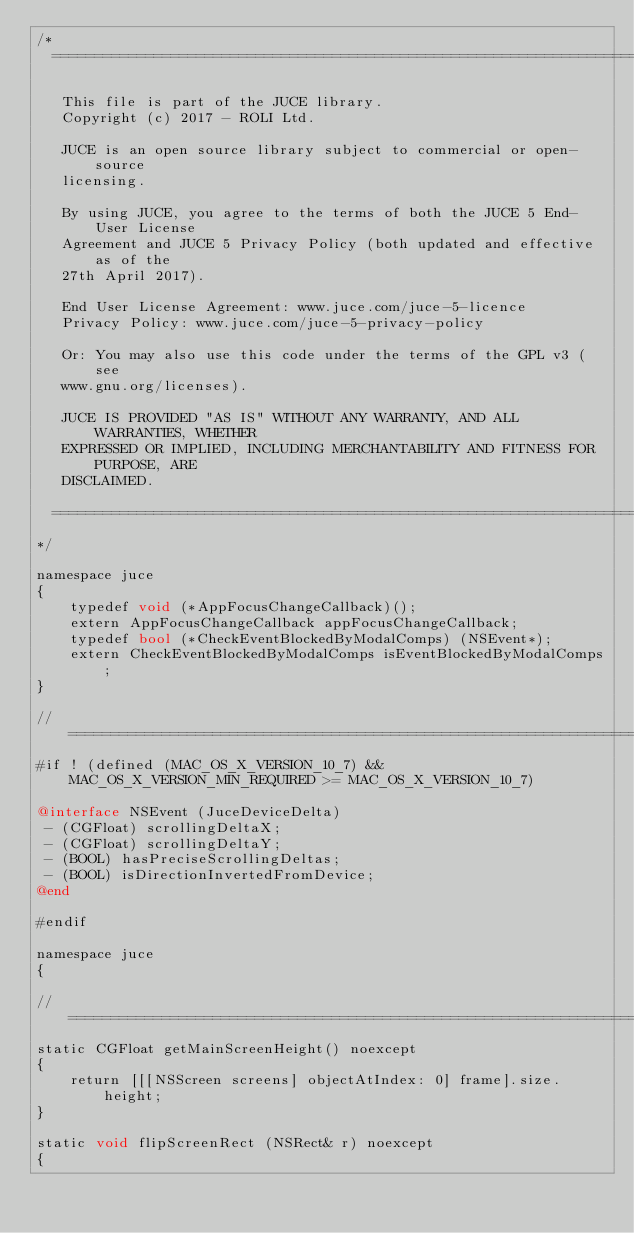<code> <loc_0><loc_0><loc_500><loc_500><_ObjectiveC_>/*
  ==============================================================================

   This file is part of the JUCE library.
   Copyright (c) 2017 - ROLI Ltd.

   JUCE is an open source library subject to commercial or open-source
   licensing.

   By using JUCE, you agree to the terms of both the JUCE 5 End-User License
   Agreement and JUCE 5 Privacy Policy (both updated and effective as of the
   27th April 2017).

   End User License Agreement: www.juce.com/juce-5-licence
   Privacy Policy: www.juce.com/juce-5-privacy-policy

   Or: You may also use this code under the terms of the GPL v3 (see
   www.gnu.org/licenses).

   JUCE IS PROVIDED "AS IS" WITHOUT ANY WARRANTY, AND ALL WARRANTIES, WHETHER
   EXPRESSED OR IMPLIED, INCLUDING MERCHANTABILITY AND FITNESS FOR PURPOSE, ARE
   DISCLAIMED.

  ==============================================================================
*/

namespace juce
{
    typedef void (*AppFocusChangeCallback)();
    extern AppFocusChangeCallback appFocusChangeCallback;
    typedef bool (*CheckEventBlockedByModalComps) (NSEvent*);
    extern CheckEventBlockedByModalComps isEventBlockedByModalComps;
}

//==============================================================================
#if ! (defined (MAC_OS_X_VERSION_10_7) && MAC_OS_X_VERSION_MIN_REQUIRED >= MAC_OS_X_VERSION_10_7)

@interface NSEvent (JuceDeviceDelta)
 - (CGFloat) scrollingDeltaX;
 - (CGFloat) scrollingDeltaY;
 - (BOOL) hasPreciseScrollingDeltas;
 - (BOOL) isDirectionInvertedFromDevice;
@end

#endif

namespace juce
{

//==============================================================================
static CGFloat getMainScreenHeight() noexcept
{
    return [[[NSScreen screens] objectAtIndex: 0] frame].size.height;
}

static void flipScreenRect (NSRect& r) noexcept
{</code> 